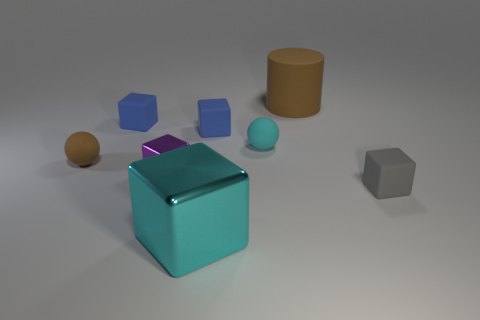Subtract 2 blocks. How many blocks are left? 3 Subtract all gray cubes. How many cubes are left? 4 Subtract all large cyan metal cubes. How many cubes are left? 4 Add 1 brown rubber cylinders. How many objects exist? 9 Subtract all yellow cubes. Subtract all cyan spheres. How many cubes are left? 5 Subtract all cubes. How many objects are left? 3 Add 1 big cyan objects. How many big cyan objects exist? 2 Subtract 0 purple spheres. How many objects are left? 8 Subtract all brown objects. Subtract all small objects. How many objects are left? 0 Add 7 purple blocks. How many purple blocks are left? 8 